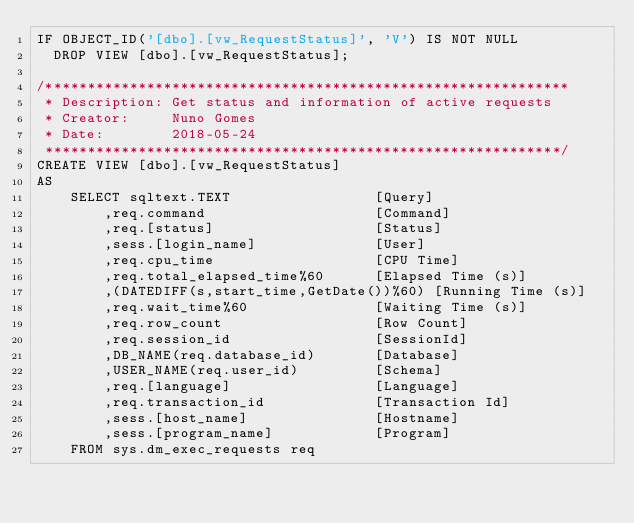<code> <loc_0><loc_0><loc_500><loc_500><_SQL_>IF OBJECT_ID('[dbo].[vw_RequestStatus]', 'V') IS NOT NULL 
  DROP VIEW [dbo].[vw_RequestStatus]; 

/**************************************************************
 * Description:	Get status and information of active requests
 * Creator:		Nuno Gomes
 * Date:		2018-05-24
 *************************************************************/
CREATE VIEW [dbo].[vw_RequestStatus]
AS
	SELECT sqltext.TEXT					[Query]
		,req.command					[Command]
		,req.[status]					[Status]
		,sess.[login_name]				[User]
		,req.cpu_time					[CPU Time]
		,req.total_elapsed_time%60		[Elapsed Time (s)]
		,(DATEDIFF(s,start_time,GetDate())%60) [Running Time (s)]
		,req.wait_time%60				[Waiting Time (s)]
		,req.row_count					[Row Count]
		,req.session_id					[SessionId]
		,DB_NAME(req.database_id)		[Database]
		,USER_NAME(req.user_id)			[Schema]
		,req.[language]					[Language]
		,req.transaction_id				[Transaction Id]
		,sess.[host_name]				[Hostname]
		,sess.[program_name]			[Program]
	FROM sys.dm_exec_requests req</code> 